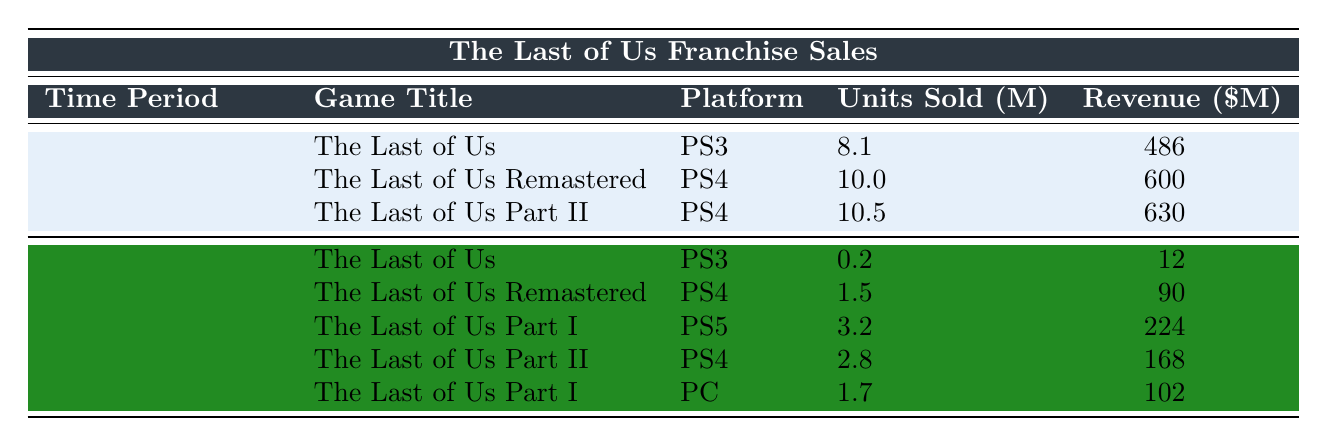What was the total units sold for "The Last of Us" games before the TV series release? The units sold for "The Last of Us" (PS3), "The Last of Us Remastered" (PS4), and "The Last of Us Part II" (PS4) before the TV series are 8.1 million, 10 million, and 10.5 million respectively. Adding these, 8.1 + 10 + 10.5 = 28.6 million units sold.
Answer: 28.6 million How much revenue did "The Last of Us Part II" generate after the TV series release? The revenue generated by "The Last of Us Part II" (PS4) after the TV series release was 168 million USD.
Answer: 168 million Did "The Last of Us Part I" generate more revenue on PS5 or PC after the TV series release? The revenue for "The Last of Us Part I" on PS5 was 224 million USD, while on PC it was 102 million USD. Since 224 > 102, it generated more revenue on PS5.
Answer: Yes, PS5 What is the total revenue for all "The Last of Us" games after the TV series release? The total revenue for all "The Last of Us" games after the TV series is calculated as follows: 12 (The Last of Us) + 90 (Remastered) + 224 (Part I on PS5) + 168 (Part II) + 102 (Part I on PC) = 596 million USD.
Answer: 596 million Which platform had the highest units sold for "The Last of Us" after the TV series release? The units sold after the series are as follows: PS3 (0.2 million), PS4 (1.5 million for Remastered and 2.8 million for Part II), PS5 (3.2 million for Part I), and PC (1.7 million for Part I). The highest is 3.2 million on PS5.
Answer: PS5 What was the average units sold for all titles before the TV series release? For the three games sold before the TV series, the units are 8.1 million, 10 million, and 10.5 million. The average is calculated by (8.1 + 10 + 10.5) / 3 = 28.6 / 3 = 9.53 million.
Answer: 9.53 million How much did the total units sold decline for "The Last of Us" and "The Last of Us Remastered" from before to after the TV series release? Before, "The Last of Us" sold 8.1 million, and after it sold 0.2 million. "The Last of Us Remastered" sold 10 million before, and after it sold 1.5 million. The decline for "The Last of Us" is 8.1 - 0.2 = 7.9 million, and for "The Last of Us Remastered" is 10 - 1.5 = 8.5 million. Adding declines gives 7.9 + 8.5 = 16.4 million total decline.
Answer: 16.4 million Which version of "The Last of Us" had the greatest increase in units sold after the TV series release compared to its prior sales? Comparing the units sold: "The Last of Us" saw a decrease, "Remastered" decreased, "Part II" also had a decrease. "Part I" was new on PS5 with 3.2 million, while PS4 and PC both contributed additional sales. Since it was released after the show, and the earlier version was not counted during this period, it can't be directly compared as an increase.
Answer: Not applicable How many units sold for "The Last of Us Part I" on PS5 and PC combined after the TV series? The sales for "The Last of Us Part I" on PS5 were 3.2 million, and on PC 1.7 million. Adding these gives 3.2 + 1.7 = 4.9 million units sold combined.
Answer: 4.9 million After the TV series release, did the overall sales figures for all titles increase or decrease compared to before? Before the series, total units sold were 28.6 million, while after the series, total units sold were 9.4 million (0.2 + 1.5 + 3.2 + 2.8 + 1.7). Comparing 28.6 million before to 9.4 million after shows a significant decrease.
Answer: Decrease 